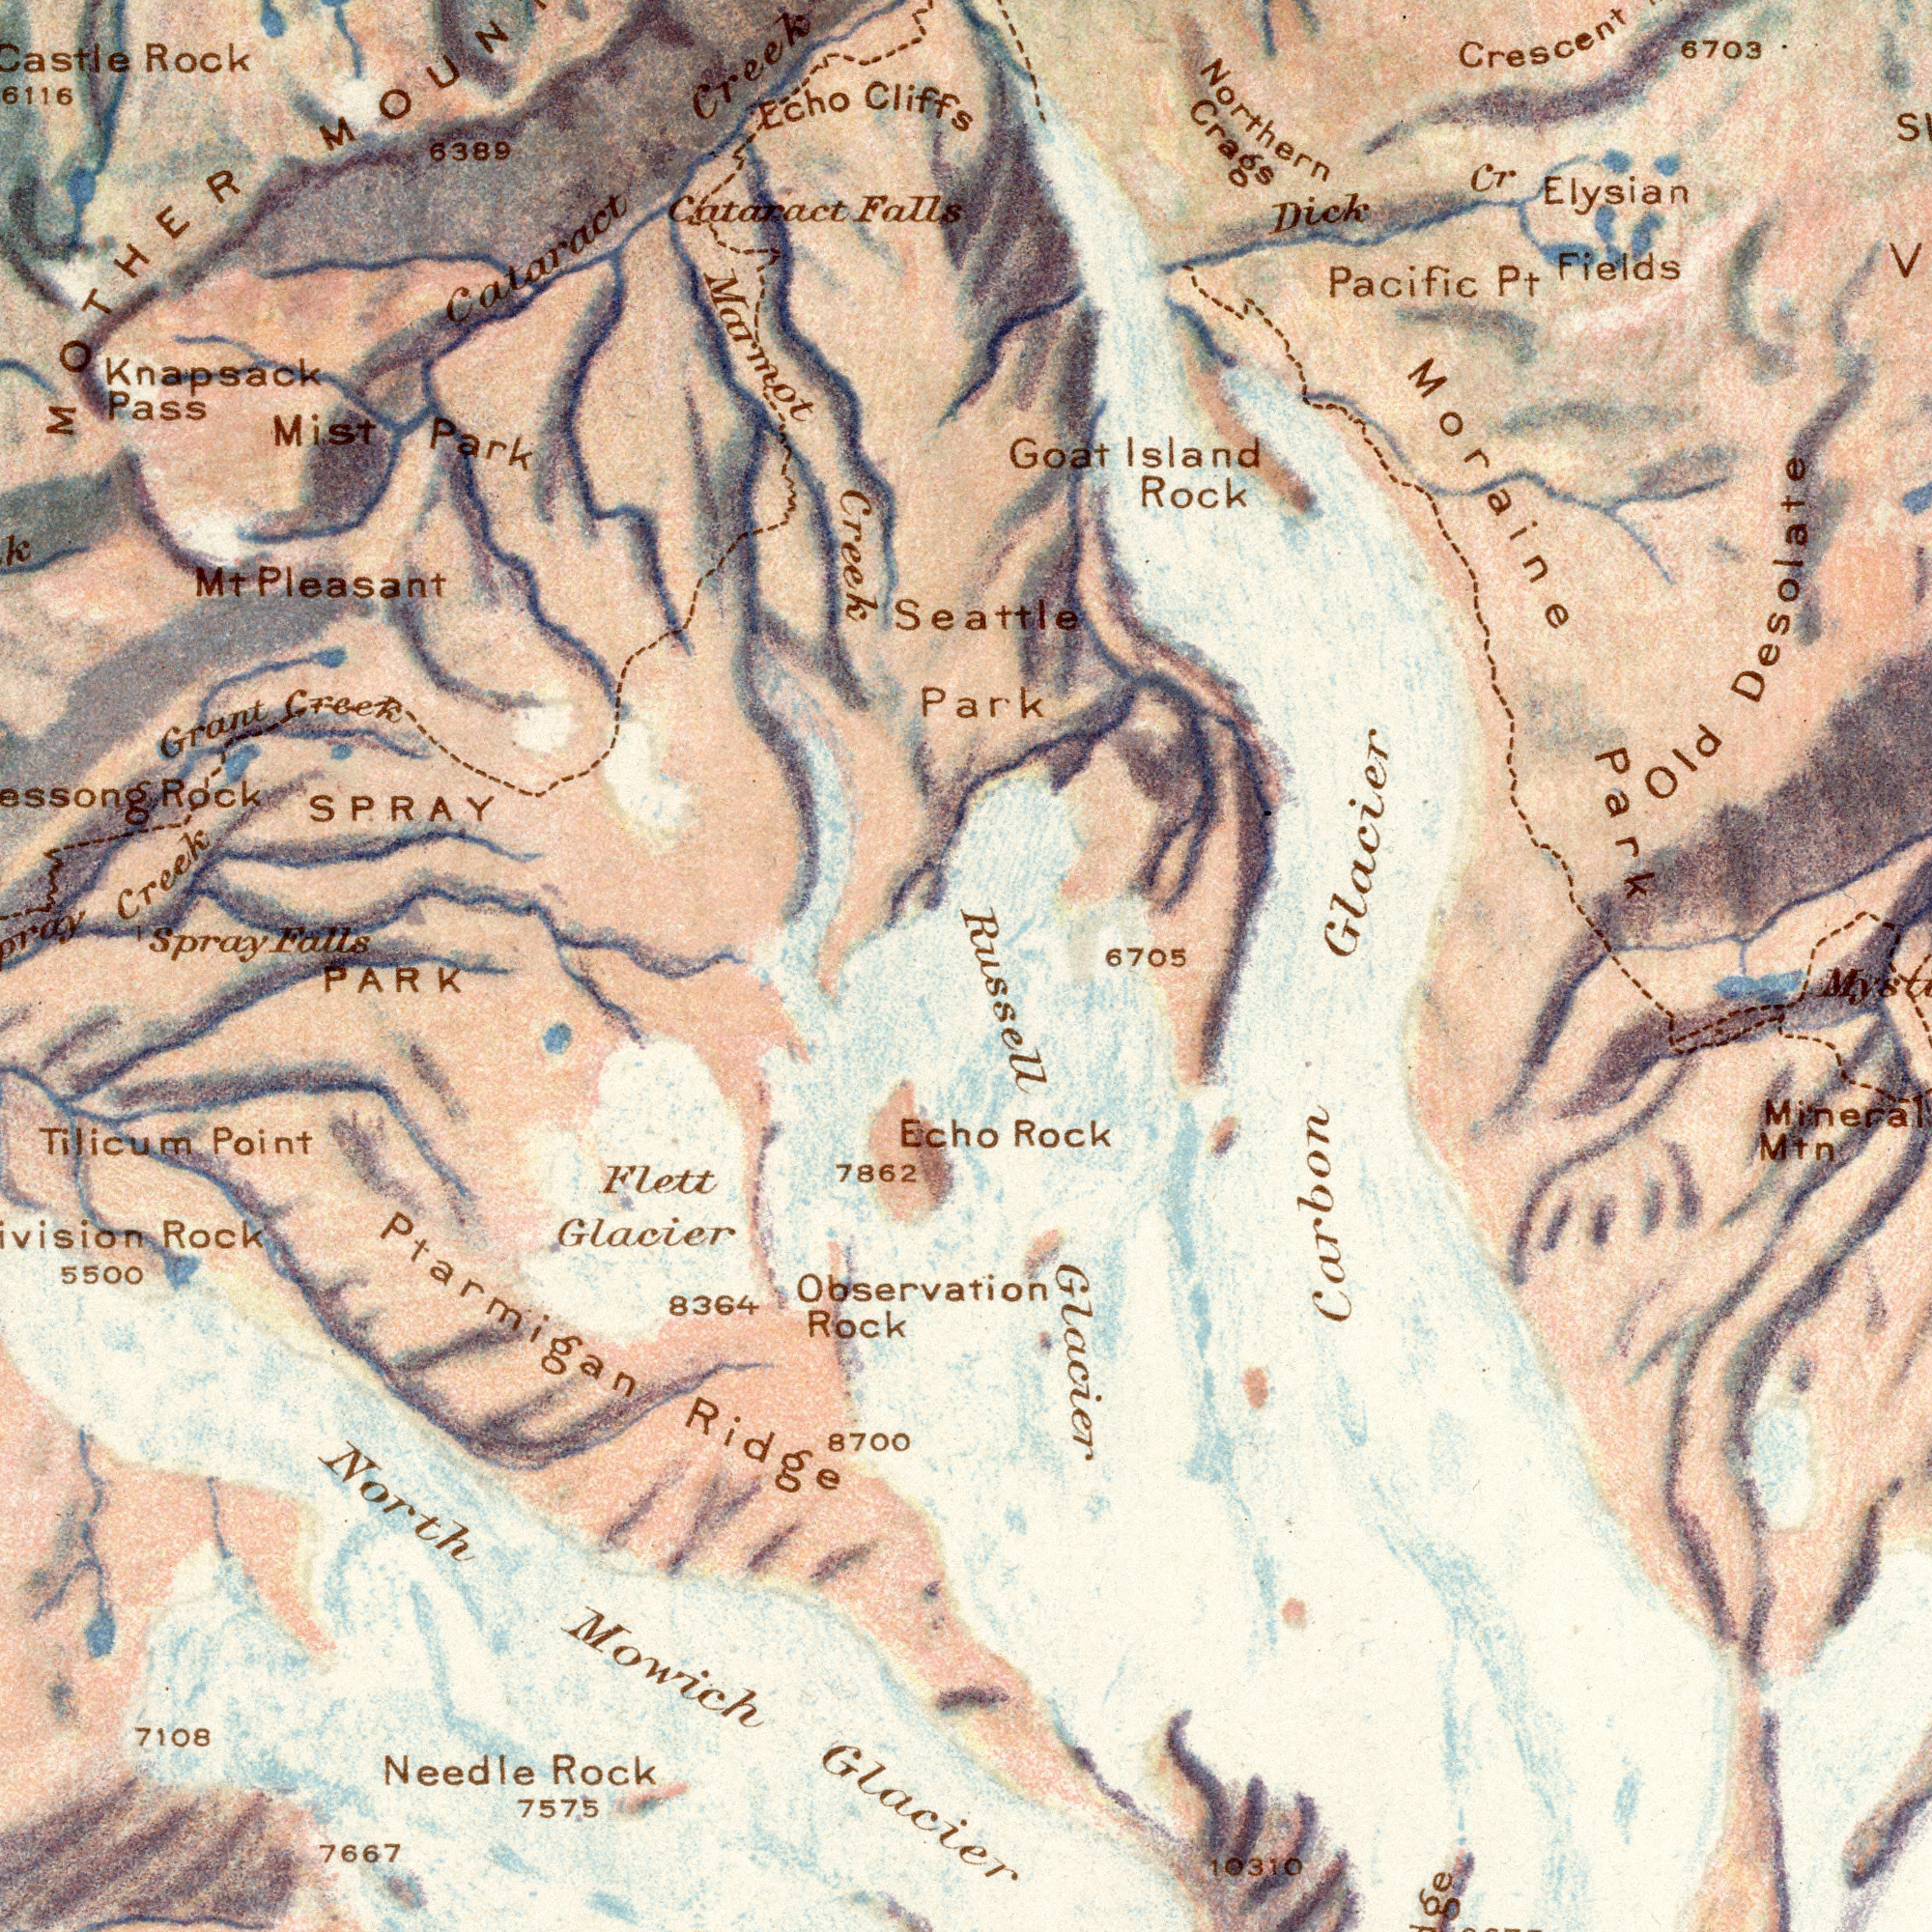What text appears in the top-left area of the image? Marmot SPRAY Spray Creek Knapsack Falls Pleasant Mist Castle Creek Rock Rock Cataract Echo Park 6116 6389 Pass Grant Cataract Cliffs Falls Mt MOTHER Creek Creek What text is visible in the lower-right corner? 6705 Mineral Rock Mtn 10310 Glacier Russell Carbon What text appears in the bottom-left area of the image? Glacier Mowich PARK 7667 North Rock Observation Flett Rock Tilicum Needle 8700 7575 7108 7862 Rock 8364 Point 5500 Glacier Ridge Ptarmigan Echo What text appears in the top-right area of the image? Seattle Park Northern Crescent Glacier Fields Dick Crags Rock Cr Pacific Park 6703 Old Desolate Moraine Elysian Pt Goat Island 